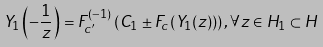Convert formula to latex. <formula><loc_0><loc_0><loc_500><loc_500>Y _ { 1 } \left ( - \frac { 1 } { z } \right ) = F ^ { ( - 1 ) } _ { c ^ { \prime } } \left ( C _ { 1 } \pm F _ { c } \left ( Y _ { 1 } ( z ) \right ) \right ) , \forall z \in H _ { 1 } \subset H</formula> 